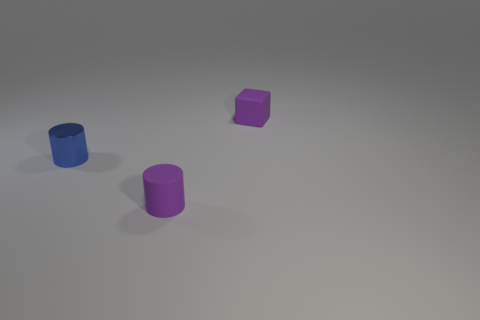Add 3 big red matte balls. How many objects exist? 6 Subtract all blocks. How many objects are left? 2 Subtract 1 blocks. How many blocks are left? 0 Subtract all cyan cylinders. Subtract all yellow cubes. How many cylinders are left? 2 Subtract all red cylinders. How many brown cubes are left? 0 Subtract all purple objects. Subtract all tiny shiny things. How many objects are left? 0 Add 1 purple cylinders. How many purple cylinders are left? 2 Add 1 small things. How many small things exist? 4 Subtract 0 red balls. How many objects are left? 3 